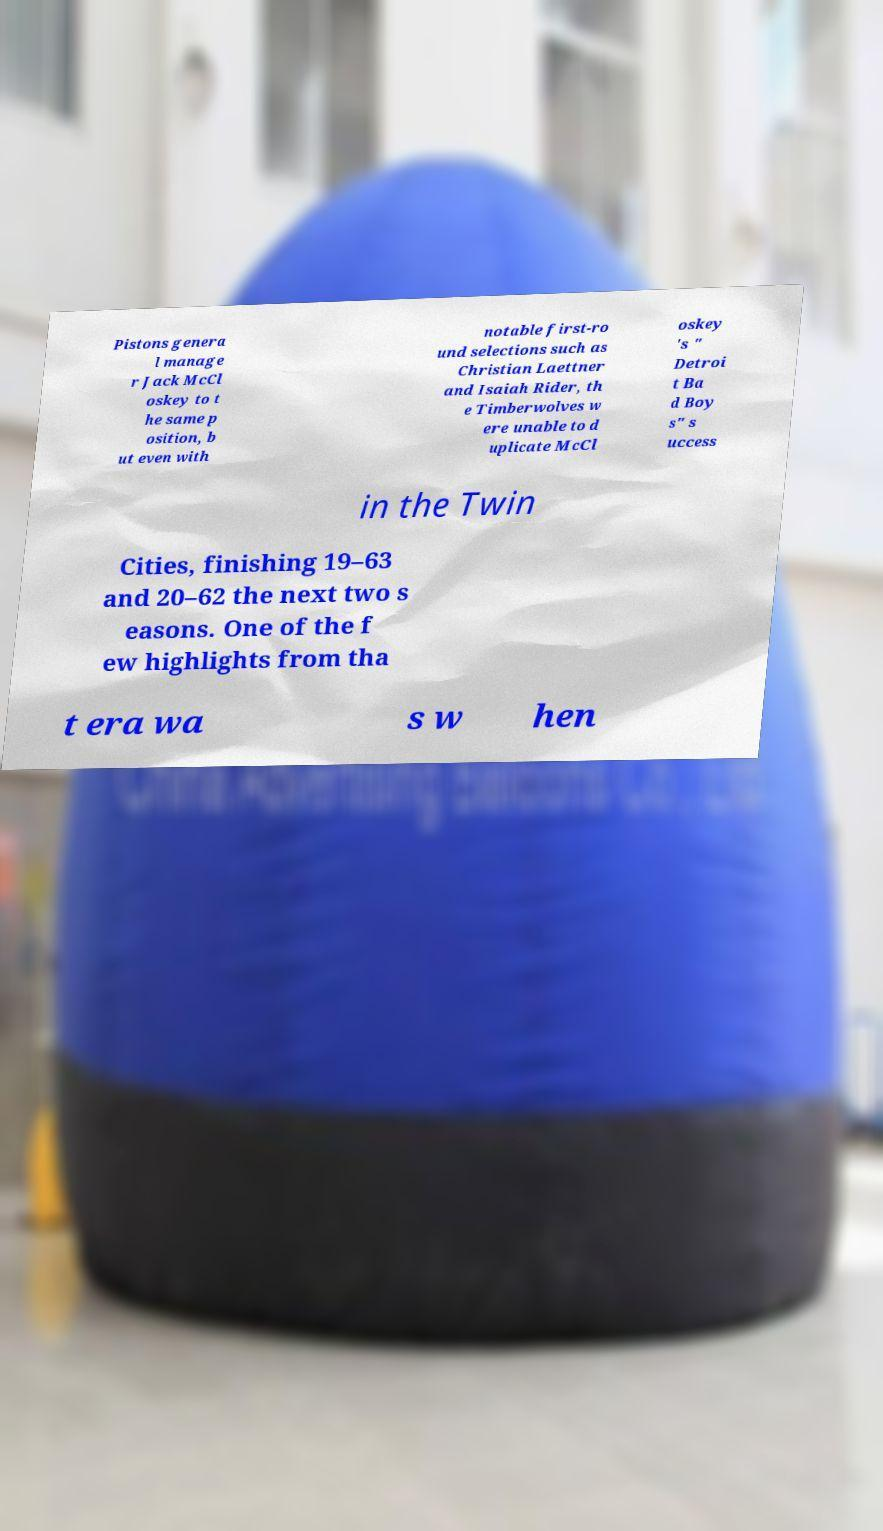Please identify and transcribe the text found in this image. Pistons genera l manage r Jack McCl oskey to t he same p osition, b ut even with notable first-ro und selections such as Christian Laettner and Isaiah Rider, th e Timberwolves w ere unable to d uplicate McCl oskey 's " Detroi t Ba d Boy s" s uccess in the Twin Cities, finishing 19–63 and 20–62 the next two s easons. One of the f ew highlights from tha t era wa s w hen 